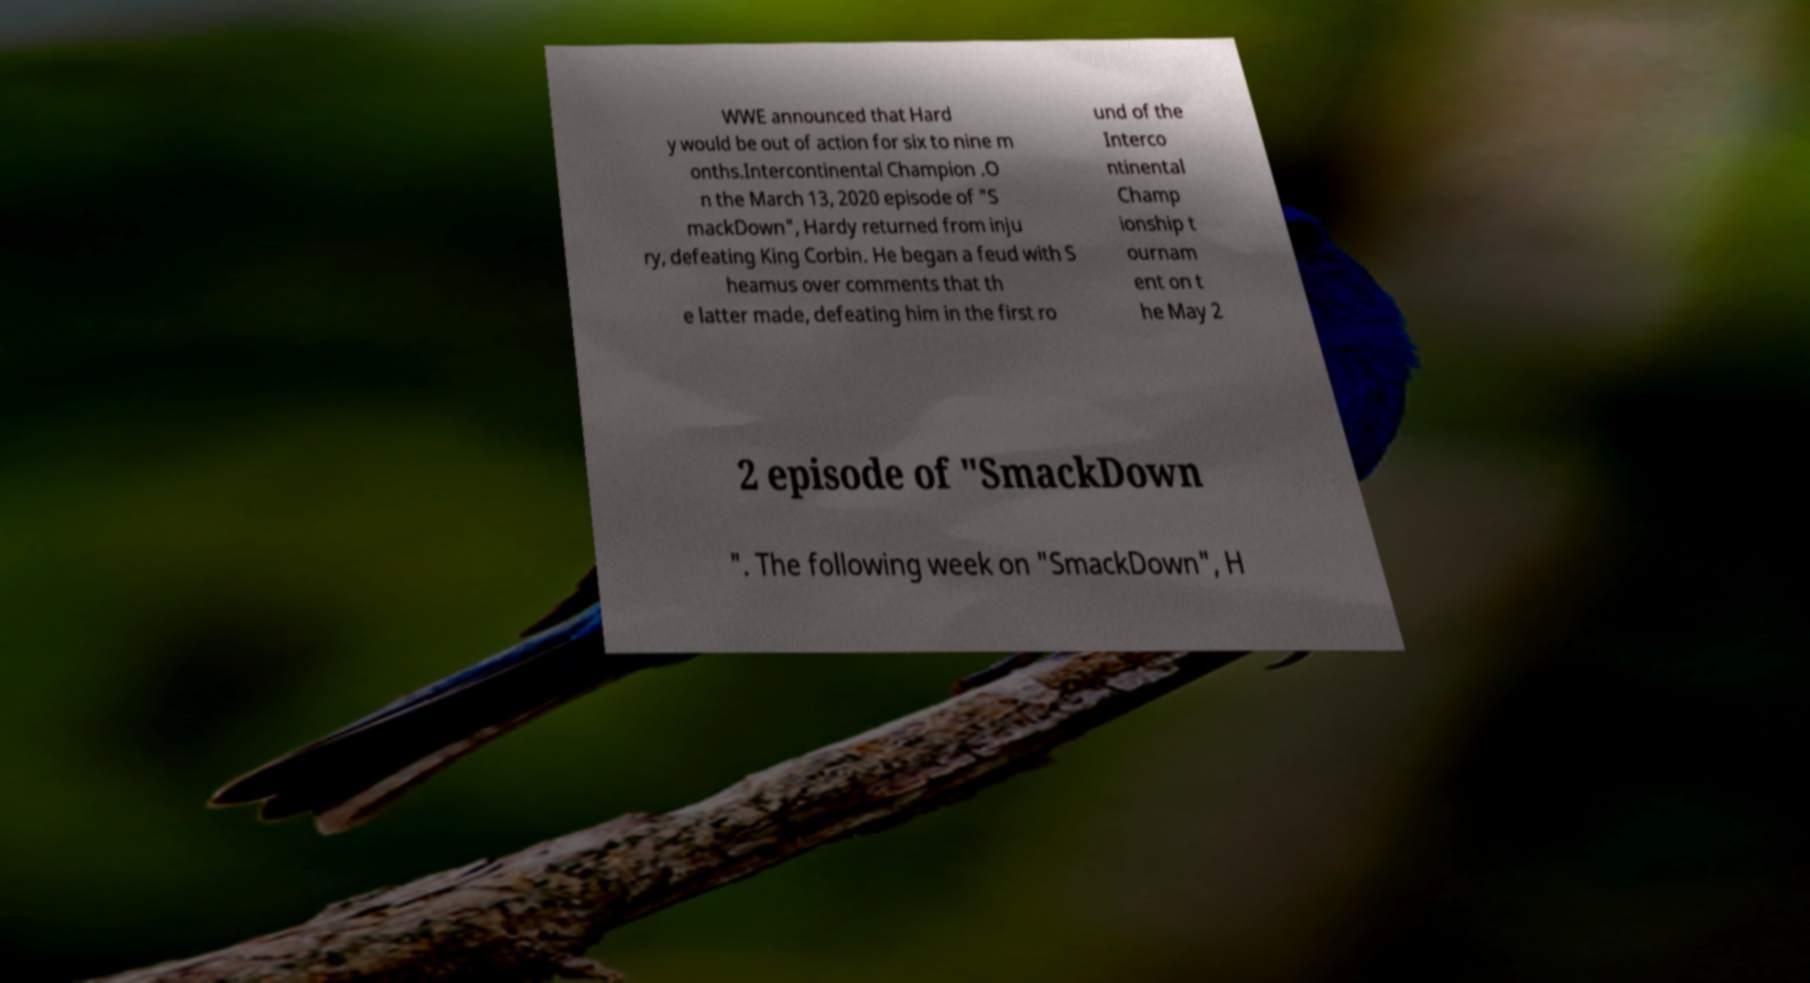Could you assist in decoding the text presented in this image and type it out clearly? WWE announced that Hard y would be out of action for six to nine m onths.Intercontinental Champion .O n the March 13, 2020 episode of "S mackDown", Hardy returned from inju ry, defeating King Corbin. He began a feud with S heamus over comments that th e latter made, defeating him in the first ro und of the Interco ntinental Champ ionship t ournam ent on t he May 2 2 episode of "SmackDown ". The following week on "SmackDown", H 